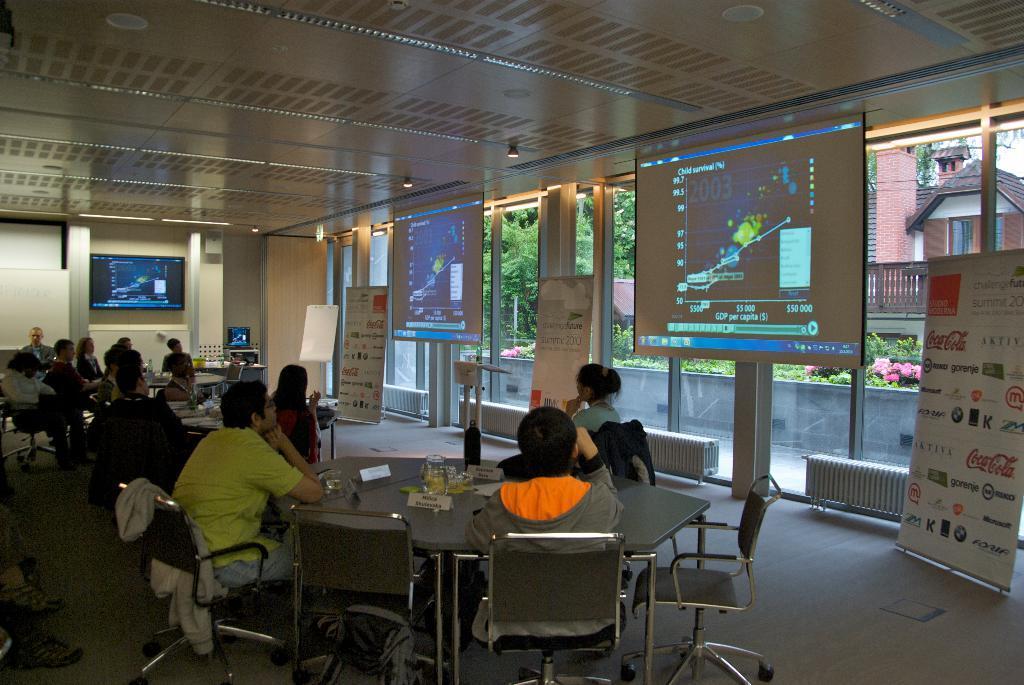How would you summarize this image in a sentence or two? In this picture of group of people sitting they have some tables in front of them with some name boards, glasses kept on it and they have some projector screens on to the right and left and there is a banner there also some empty chairs and ceiling with some lights and in the backdrop there are some trees 